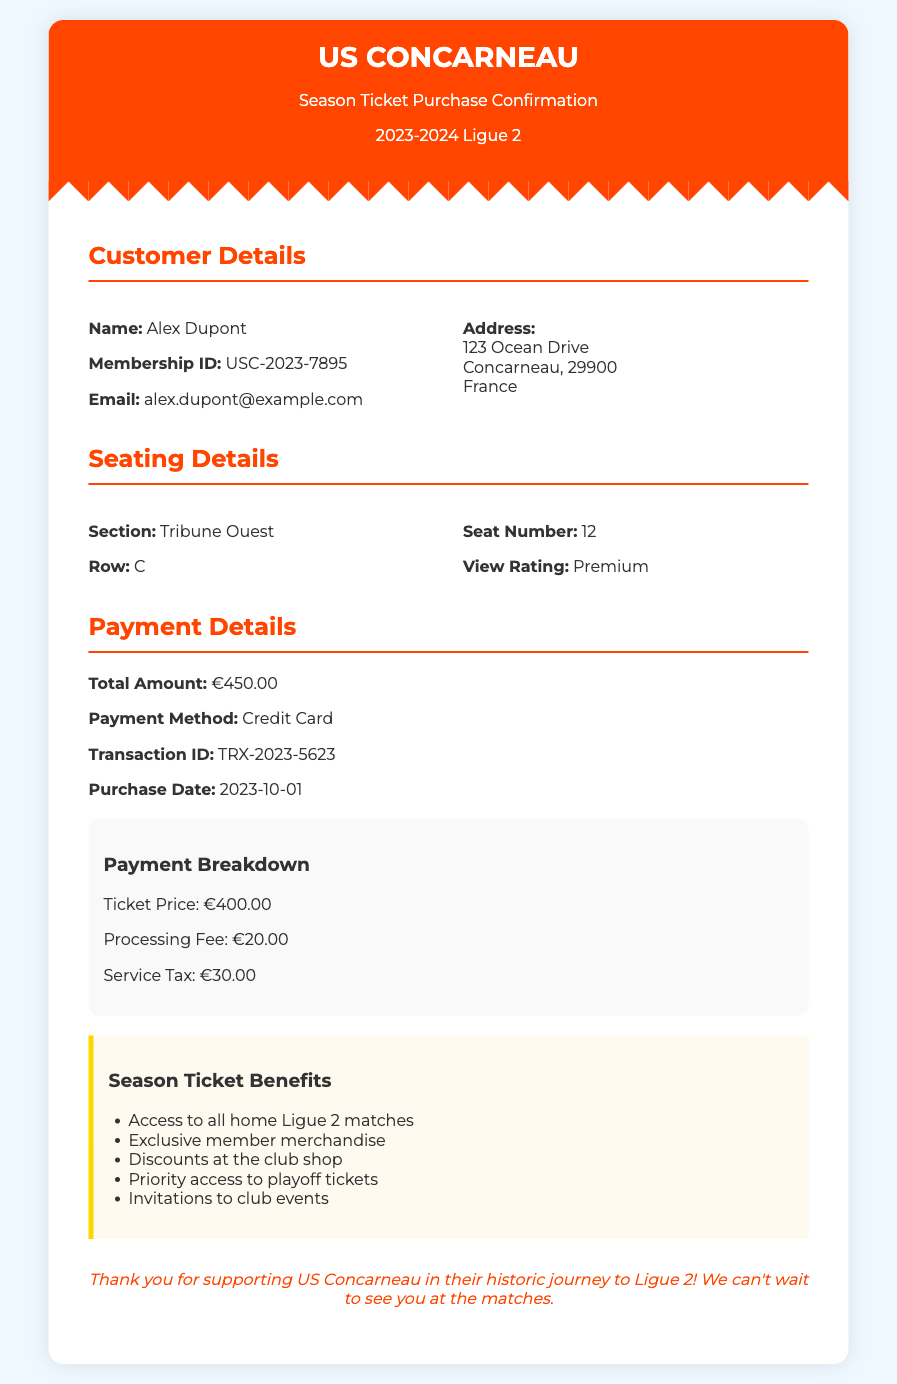What is the name of the customer? The customer's name is listed in the document under Customer Details, which shows "Alex Dupont."
Answer: Alex Dupont What is the transaction ID? The transaction ID is provided in the Payment Details section; it is a unique identifier for the transaction.
Answer: TRX-2023-5623 What is the total amount paid for the season ticket? The total amount is found in the Payment Details section, indicating the overall cost of the ticket.
Answer: €450.00 Which payment method was used? The payment method used for the transaction is specified in the Payment Details section.
Answer: Credit Card What is the seat number? The seat number is mentioned in the Seating Details section, highlighting where the customer will sit during matches.
Answer: 12 What benefits come with the season ticket? The benefits of the season ticket are listed in a specific section that outlines what the ticket holder receives.
Answer: Access to all home Ligue 2 matches How much is the processing fee? The processing fee is detailed in the Payment Breakdown, showing the additional costs incurred with the purchase.
Answer: €20.00 What row is the seat located in? The specific row for the customer's seat is stated in the Seating Details, outlining the exact seating arrangement.
Answer: C When was the purchase made? The purchase date is noted in the Payment Details section, indicating when the transaction occurred.
Answer: 2023-10-01 